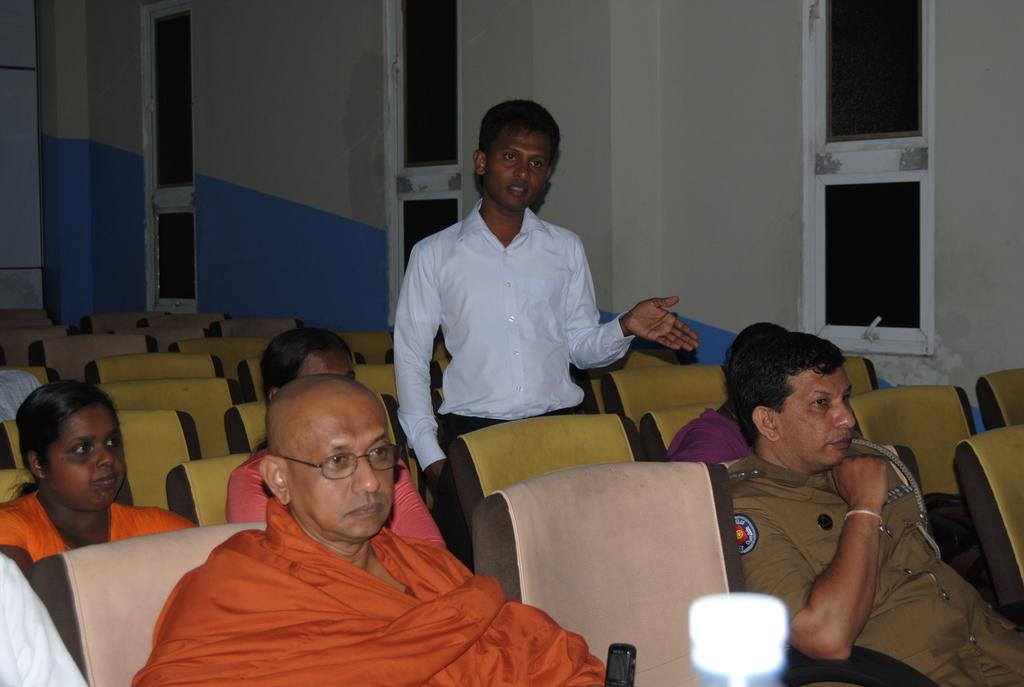How many people are in the image? There is a group of people in the image. What are the people doing in the image? The people are sitting on chairs. What can be seen in the background of the image? There is a wall and windows in the background of the image. Where was the image taken? The image was taken in a hall. Is there a pool visible in the image where the people are swimming? No, there is no pool or swimming activity visible in the image. 